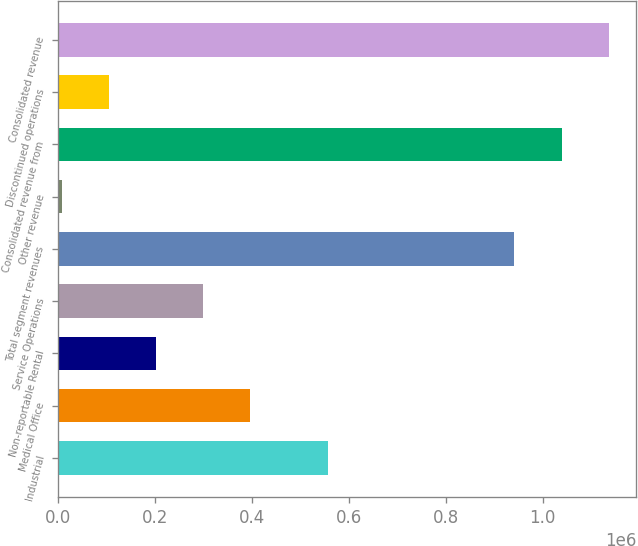Convert chart to OTSL. <chart><loc_0><loc_0><loc_500><loc_500><bar_chart><fcel>Industrial<fcel>Medical Office<fcel>Non-reportable Rental<fcel>Service Operations<fcel>Total segment revenues<fcel>Other revenue<fcel>Consolidated revenue from<fcel>Discontinued operations<fcel>Consolidated revenue<nl><fcel>556903<fcel>397286<fcel>202387<fcel>299837<fcel>941943<fcel>7489<fcel>1.03939e+06<fcel>104938<fcel>1.13684e+06<nl></chart> 